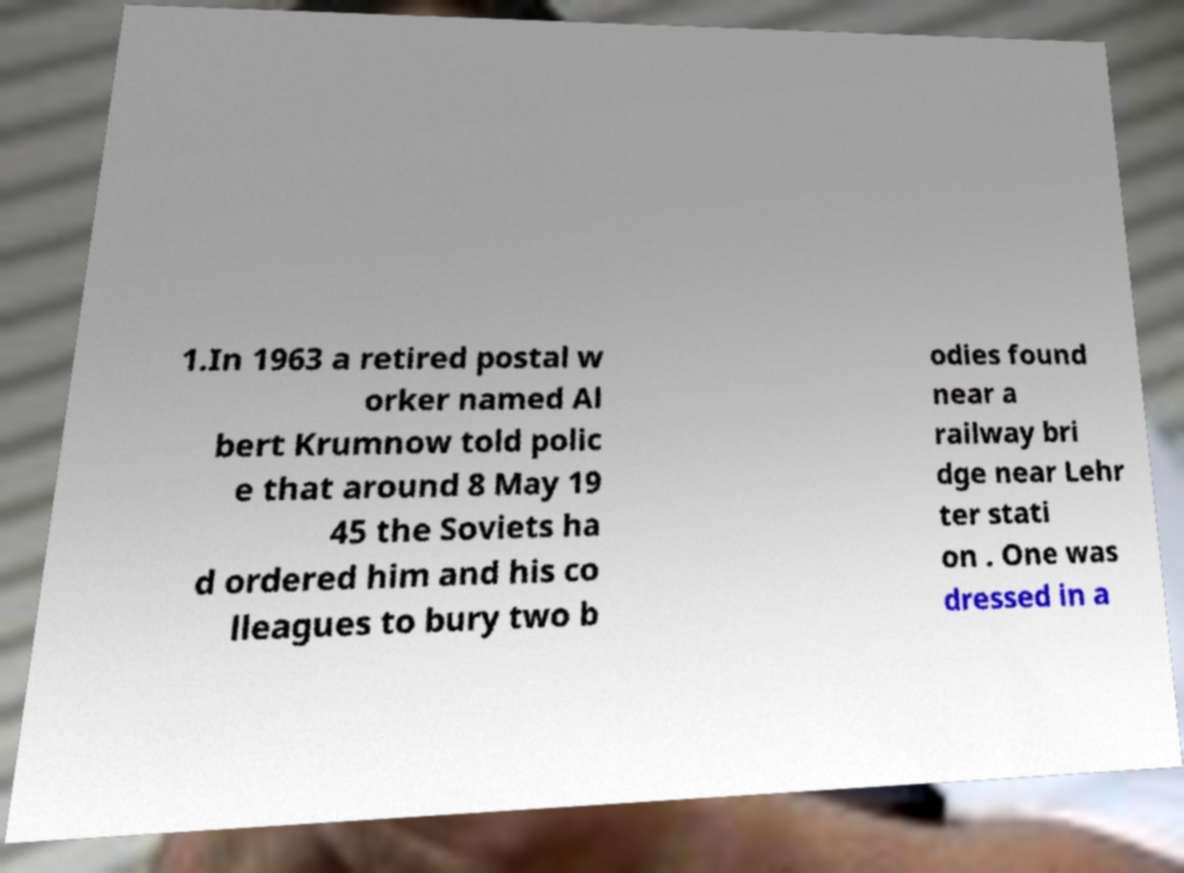Can you read and provide the text displayed in the image?This photo seems to have some interesting text. Can you extract and type it out for me? 1.In 1963 a retired postal w orker named Al bert Krumnow told polic e that around 8 May 19 45 the Soviets ha d ordered him and his co lleagues to bury two b odies found near a railway bri dge near Lehr ter stati on . One was dressed in a 